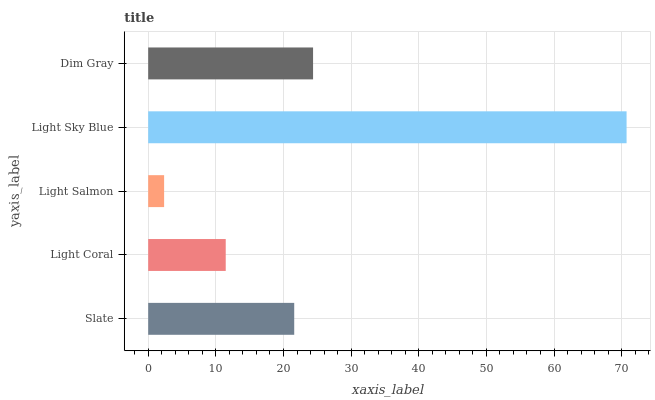Is Light Salmon the minimum?
Answer yes or no. Yes. Is Light Sky Blue the maximum?
Answer yes or no. Yes. Is Light Coral the minimum?
Answer yes or no. No. Is Light Coral the maximum?
Answer yes or no. No. Is Slate greater than Light Coral?
Answer yes or no. Yes. Is Light Coral less than Slate?
Answer yes or no. Yes. Is Light Coral greater than Slate?
Answer yes or no. No. Is Slate less than Light Coral?
Answer yes or no. No. Is Slate the high median?
Answer yes or no. Yes. Is Slate the low median?
Answer yes or no. Yes. Is Dim Gray the high median?
Answer yes or no. No. Is Light Coral the low median?
Answer yes or no. No. 